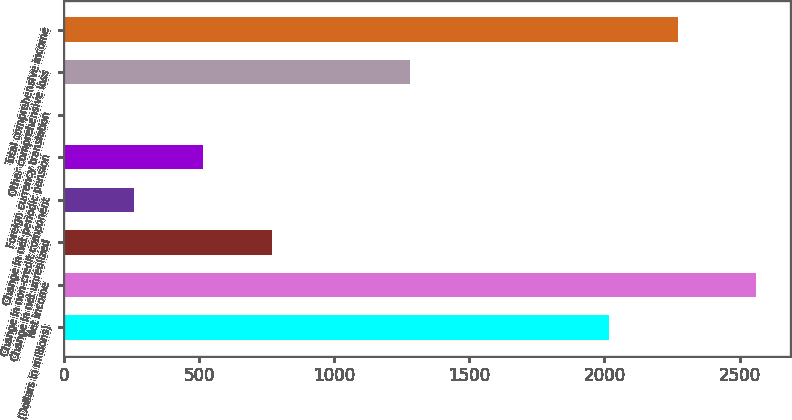<chart> <loc_0><loc_0><loc_500><loc_500><bar_chart><fcel>(Dollars in millions)<fcel>Net income<fcel>Change in net unrealized<fcel>Change in non-credit component<fcel>Change in net periodic pension<fcel>Foreign currency translation<fcel>Other comprehensive loss<fcel>Total comprehensive income<nl><fcel>2015<fcel>2560<fcel>770.38<fcel>259.06<fcel>514.72<fcel>3.4<fcel>1281.7<fcel>2270.66<nl></chart> 